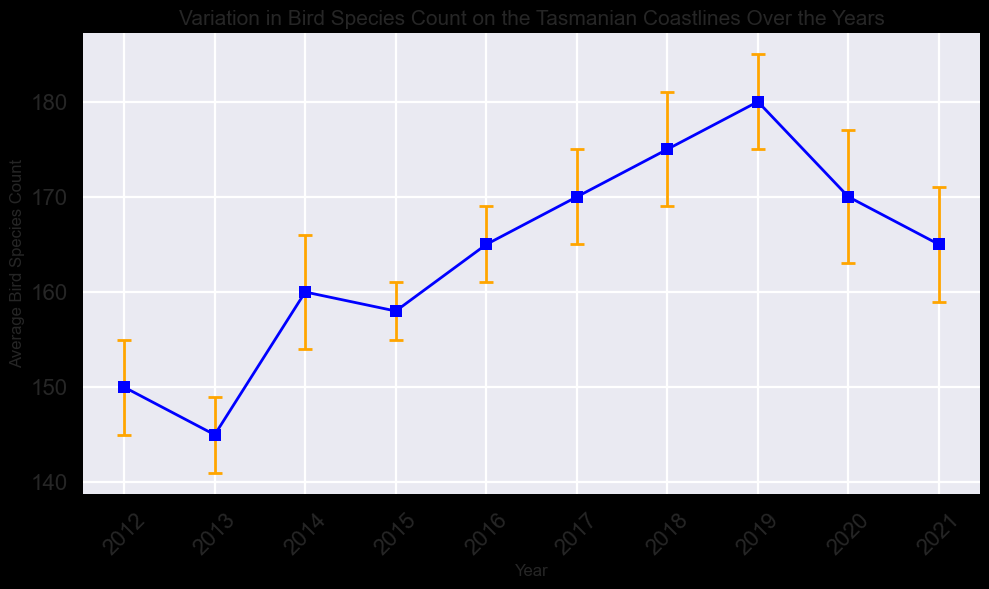What year had the highest average bird species count? The year with the highest point on the graph represents the highest average bird species count. According to the figure, the highest point is in 2019 with an average count of 180.
Answer: 2019 Which two consecutive years had the greatest increase in average bird species count? We need to calculate the difference in bird species count between each pair of consecutive years and find the pair with the largest positive difference. The counts increase by (160-145) = 15 from 2013 to 2014, (165-158) = 7 from 2015 to 2016, (170-165) = 5 from 2016 to 2017, (175-170) = 5 from 2017 to 2018, and (180-175) = 5 from 2018 to 2019. The greatest increase is 15, which occurred between 2013 and 2014.
Answer: 2013 to 2014 What is the average bird species count for the decade shown? To find the average for all years, sum the average counts and divide by the number of years. The total is 150 + 145 + 160 + 158 + 165 + 170 + 175 + 180 + 170 + 165 = 1638. Dividing by 10 (years) gives 163.8.
Answer: 163.8 Between which years did the average bird species count decrease? Observing the graph, look for downward trends between consecutive years. The average count decreases between 2012 to 2013, 2019 to 2020, and 2020 to 2021.
Answer: 2012 to 2013, 2019 to 2020, 2020 to 2021 Which year has the most considerable error margin shown in the figure? The year with the longest error bar (vertical line) indicates the most considerable error margin. According to the graph, in 2020, the error margin is the largest at 7.
Answer: 2020 What is the trend in bird species count from 2017 to 2019? Observe the points and error bars from 2017 to 2019. The trend shows a clear increase: from 170 in 2017 to 175 in 2018 to 180 in 2019.
Answer: Increase In which year was the bird species count closest to 160? Looking at the counts, the points nearest to 160 are in 2014. The actual count for that year is precisely 160.
Answer: 2014 What is the difference in bird species count between 2013 and 2017? Subtract the average count for 2013 from the average count for 2017. The difference is 170 - 145 = 25.
Answer: 25 Identify the year where the bird species count remained the same or declined since the previous year. Check each year’s counts relative to the preceding year. The count declined or remained same from 2012 to 2013, 2019 to 2020, and 2020 to 2021.
Answer: 2012 to 2013, 2019 to 2020, 2020 to 2021 